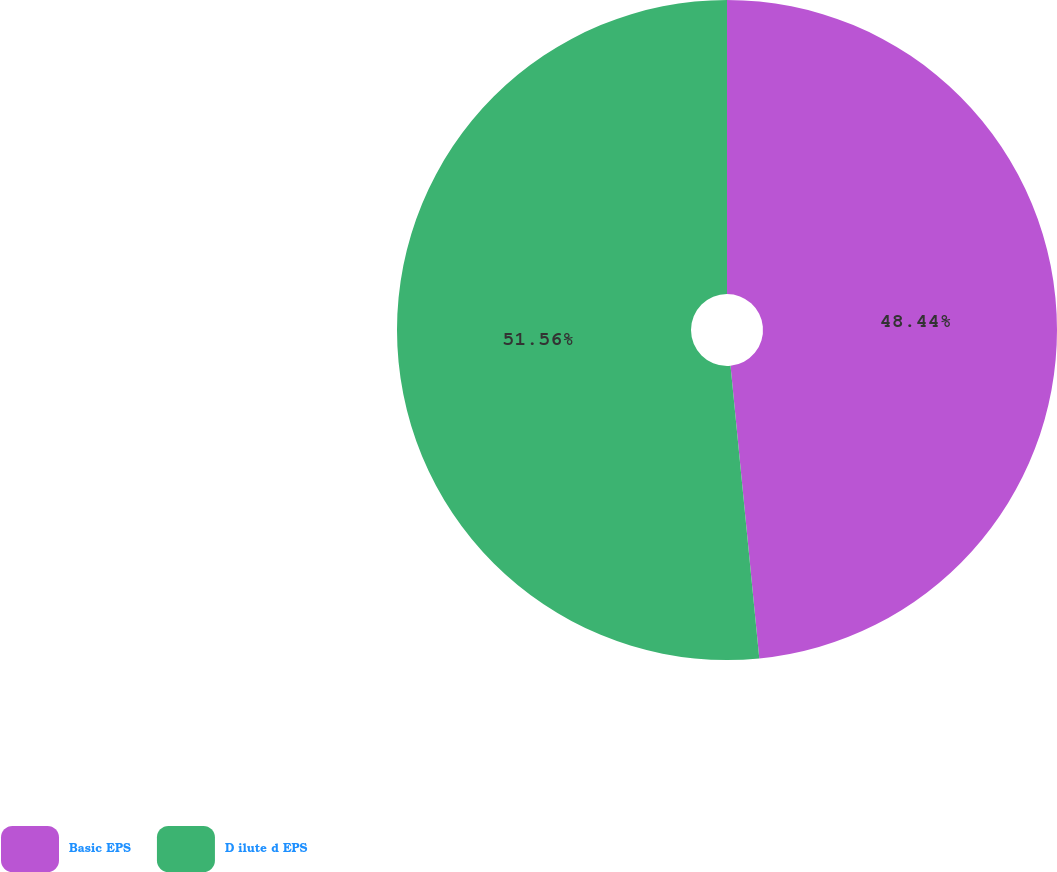Convert chart. <chart><loc_0><loc_0><loc_500><loc_500><pie_chart><fcel>Basic EPS<fcel>D ilute d EPS<nl><fcel>48.44%<fcel>51.56%<nl></chart> 